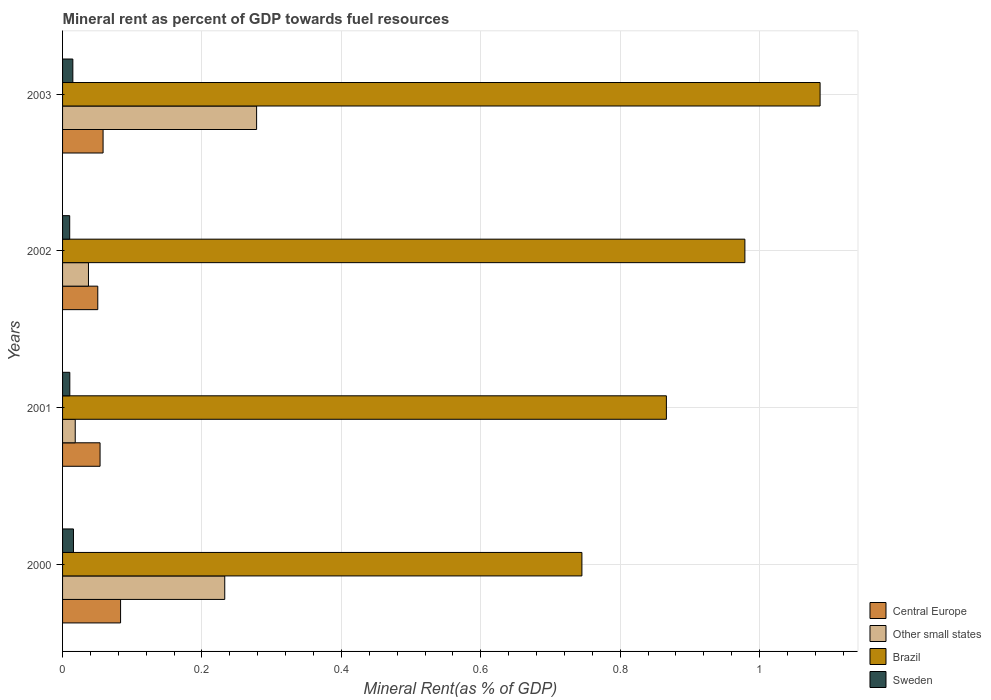How many different coloured bars are there?
Ensure brevity in your answer.  4. Are the number of bars on each tick of the Y-axis equal?
Ensure brevity in your answer.  Yes. How many bars are there on the 2nd tick from the top?
Offer a terse response. 4. What is the label of the 1st group of bars from the top?
Make the answer very short. 2003. In how many cases, is the number of bars for a given year not equal to the number of legend labels?
Make the answer very short. 0. What is the mineral rent in Central Europe in 2000?
Offer a very short reply. 0.08. Across all years, what is the maximum mineral rent in Sweden?
Make the answer very short. 0.02. Across all years, what is the minimum mineral rent in Sweden?
Your answer should be compact. 0.01. In which year was the mineral rent in Brazil maximum?
Your answer should be compact. 2003. What is the total mineral rent in Brazil in the graph?
Your answer should be very brief. 3.68. What is the difference between the mineral rent in Sweden in 2000 and that in 2003?
Make the answer very short. 0. What is the difference between the mineral rent in Sweden in 2001 and the mineral rent in Other small states in 2003?
Ensure brevity in your answer.  -0.27. What is the average mineral rent in Other small states per year?
Your answer should be compact. 0.14. In the year 2003, what is the difference between the mineral rent in Brazil and mineral rent in Sweden?
Offer a terse response. 1.07. What is the ratio of the mineral rent in Central Europe in 2000 to that in 2002?
Provide a short and direct response. 1.65. Is the mineral rent in Other small states in 2002 less than that in 2003?
Your answer should be compact. Yes. Is the difference between the mineral rent in Brazil in 2000 and 2001 greater than the difference between the mineral rent in Sweden in 2000 and 2001?
Make the answer very short. No. What is the difference between the highest and the second highest mineral rent in Sweden?
Make the answer very short. 0. What is the difference between the highest and the lowest mineral rent in Other small states?
Provide a succinct answer. 0.26. Is it the case that in every year, the sum of the mineral rent in Sweden and mineral rent in Central Europe is greater than the sum of mineral rent in Brazil and mineral rent in Other small states?
Offer a very short reply. Yes. What does the 4th bar from the top in 2000 represents?
Your answer should be very brief. Central Europe. What does the 1st bar from the bottom in 2000 represents?
Provide a short and direct response. Central Europe. Is it the case that in every year, the sum of the mineral rent in Brazil and mineral rent in Other small states is greater than the mineral rent in Sweden?
Keep it short and to the point. Yes. How many bars are there?
Keep it short and to the point. 16. Are the values on the major ticks of X-axis written in scientific E-notation?
Your response must be concise. No. Does the graph contain any zero values?
Provide a short and direct response. No. Where does the legend appear in the graph?
Offer a terse response. Bottom right. How many legend labels are there?
Make the answer very short. 4. What is the title of the graph?
Ensure brevity in your answer.  Mineral rent as percent of GDP towards fuel resources. Does "Dominican Republic" appear as one of the legend labels in the graph?
Your answer should be very brief. No. What is the label or title of the X-axis?
Provide a succinct answer. Mineral Rent(as % of GDP). What is the label or title of the Y-axis?
Provide a short and direct response. Years. What is the Mineral Rent(as % of GDP) in Central Europe in 2000?
Your answer should be compact. 0.08. What is the Mineral Rent(as % of GDP) in Other small states in 2000?
Offer a very short reply. 0.23. What is the Mineral Rent(as % of GDP) in Brazil in 2000?
Your answer should be very brief. 0.75. What is the Mineral Rent(as % of GDP) of Sweden in 2000?
Your answer should be very brief. 0.02. What is the Mineral Rent(as % of GDP) of Central Europe in 2001?
Your answer should be compact. 0.05. What is the Mineral Rent(as % of GDP) in Other small states in 2001?
Your answer should be very brief. 0.02. What is the Mineral Rent(as % of GDP) in Brazil in 2001?
Your answer should be very brief. 0.87. What is the Mineral Rent(as % of GDP) of Sweden in 2001?
Ensure brevity in your answer.  0.01. What is the Mineral Rent(as % of GDP) in Central Europe in 2002?
Offer a very short reply. 0.05. What is the Mineral Rent(as % of GDP) in Other small states in 2002?
Make the answer very short. 0.04. What is the Mineral Rent(as % of GDP) of Brazil in 2002?
Ensure brevity in your answer.  0.98. What is the Mineral Rent(as % of GDP) of Sweden in 2002?
Your answer should be very brief. 0.01. What is the Mineral Rent(as % of GDP) in Central Europe in 2003?
Keep it short and to the point. 0.06. What is the Mineral Rent(as % of GDP) of Other small states in 2003?
Provide a succinct answer. 0.28. What is the Mineral Rent(as % of GDP) of Brazil in 2003?
Your answer should be very brief. 1.09. What is the Mineral Rent(as % of GDP) of Sweden in 2003?
Ensure brevity in your answer.  0.01. Across all years, what is the maximum Mineral Rent(as % of GDP) in Central Europe?
Provide a succinct answer. 0.08. Across all years, what is the maximum Mineral Rent(as % of GDP) of Other small states?
Offer a very short reply. 0.28. Across all years, what is the maximum Mineral Rent(as % of GDP) of Brazil?
Your answer should be compact. 1.09. Across all years, what is the maximum Mineral Rent(as % of GDP) in Sweden?
Your answer should be very brief. 0.02. Across all years, what is the minimum Mineral Rent(as % of GDP) in Central Europe?
Offer a terse response. 0.05. Across all years, what is the minimum Mineral Rent(as % of GDP) in Other small states?
Provide a short and direct response. 0.02. Across all years, what is the minimum Mineral Rent(as % of GDP) of Brazil?
Ensure brevity in your answer.  0.75. Across all years, what is the minimum Mineral Rent(as % of GDP) in Sweden?
Your answer should be very brief. 0.01. What is the total Mineral Rent(as % of GDP) in Central Europe in the graph?
Offer a terse response. 0.25. What is the total Mineral Rent(as % of GDP) in Other small states in the graph?
Offer a very short reply. 0.57. What is the total Mineral Rent(as % of GDP) of Brazil in the graph?
Make the answer very short. 3.68. What is the total Mineral Rent(as % of GDP) in Sweden in the graph?
Your answer should be very brief. 0.05. What is the difference between the Mineral Rent(as % of GDP) in Central Europe in 2000 and that in 2001?
Your response must be concise. 0.03. What is the difference between the Mineral Rent(as % of GDP) of Other small states in 2000 and that in 2001?
Provide a short and direct response. 0.21. What is the difference between the Mineral Rent(as % of GDP) of Brazil in 2000 and that in 2001?
Keep it short and to the point. -0.12. What is the difference between the Mineral Rent(as % of GDP) in Sweden in 2000 and that in 2001?
Offer a terse response. 0.01. What is the difference between the Mineral Rent(as % of GDP) of Central Europe in 2000 and that in 2002?
Your answer should be very brief. 0.03. What is the difference between the Mineral Rent(as % of GDP) of Other small states in 2000 and that in 2002?
Offer a terse response. 0.2. What is the difference between the Mineral Rent(as % of GDP) of Brazil in 2000 and that in 2002?
Provide a succinct answer. -0.23. What is the difference between the Mineral Rent(as % of GDP) of Sweden in 2000 and that in 2002?
Give a very brief answer. 0.01. What is the difference between the Mineral Rent(as % of GDP) of Central Europe in 2000 and that in 2003?
Give a very brief answer. 0.03. What is the difference between the Mineral Rent(as % of GDP) in Other small states in 2000 and that in 2003?
Your response must be concise. -0.05. What is the difference between the Mineral Rent(as % of GDP) of Brazil in 2000 and that in 2003?
Provide a short and direct response. -0.34. What is the difference between the Mineral Rent(as % of GDP) in Sweden in 2000 and that in 2003?
Provide a short and direct response. 0. What is the difference between the Mineral Rent(as % of GDP) of Central Europe in 2001 and that in 2002?
Keep it short and to the point. 0. What is the difference between the Mineral Rent(as % of GDP) in Other small states in 2001 and that in 2002?
Give a very brief answer. -0.02. What is the difference between the Mineral Rent(as % of GDP) in Brazil in 2001 and that in 2002?
Give a very brief answer. -0.11. What is the difference between the Mineral Rent(as % of GDP) in Central Europe in 2001 and that in 2003?
Your answer should be compact. -0. What is the difference between the Mineral Rent(as % of GDP) in Other small states in 2001 and that in 2003?
Provide a short and direct response. -0.26. What is the difference between the Mineral Rent(as % of GDP) in Brazil in 2001 and that in 2003?
Provide a short and direct response. -0.22. What is the difference between the Mineral Rent(as % of GDP) in Sweden in 2001 and that in 2003?
Your response must be concise. -0. What is the difference between the Mineral Rent(as % of GDP) in Central Europe in 2002 and that in 2003?
Your answer should be compact. -0.01. What is the difference between the Mineral Rent(as % of GDP) in Other small states in 2002 and that in 2003?
Ensure brevity in your answer.  -0.24. What is the difference between the Mineral Rent(as % of GDP) of Brazil in 2002 and that in 2003?
Your answer should be compact. -0.11. What is the difference between the Mineral Rent(as % of GDP) of Sweden in 2002 and that in 2003?
Make the answer very short. -0. What is the difference between the Mineral Rent(as % of GDP) in Central Europe in 2000 and the Mineral Rent(as % of GDP) in Other small states in 2001?
Provide a succinct answer. 0.07. What is the difference between the Mineral Rent(as % of GDP) of Central Europe in 2000 and the Mineral Rent(as % of GDP) of Brazil in 2001?
Make the answer very short. -0.78. What is the difference between the Mineral Rent(as % of GDP) of Central Europe in 2000 and the Mineral Rent(as % of GDP) of Sweden in 2001?
Offer a terse response. 0.07. What is the difference between the Mineral Rent(as % of GDP) of Other small states in 2000 and the Mineral Rent(as % of GDP) of Brazil in 2001?
Ensure brevity in your answer.  -0.63. What is the difference between the Mineral Rent(as % of GDP) in Other small states in 2000 and the Mineral Rent(as % of GDP) in Sweden in 2001?
Your answer should be very brief. 0.22. What is the difference between the Mineral Rent(as % of GDP) of Brazil in 2000 and the Mineral Rent(as % of GDP) of Sweden in 2001?
Ensure brevity in your answer.  0.73. What is the difference between the Mineral Rent(as % of GDP) of Central Europe in 2000 and the Mineral Rent(as % of GDP) of Other small states in 2002?
Offer a terse response. 0.05. What is the difference between the Mineral Rent(as % of GDP) in Central Europe in 2000 and the Mineral Rent(as % of GDP) in Brazil in 2002?
Offer a terse response. -0.9. What is the difference between the Mineral Rent(as % of GDP) of Central Europe in 2000 and the Mineral Rent(as % of GDP) of Sweden in 2002?
Keep it short and to the point. 0.07. What is the difference between the Mineral Rent(as % of GDP) of Other small states in 2000 and the Mineral Rent(as % of GDP) of Brazil in 2002?
Your answer should be very brief. -0.75. What is the difference between the Mineral Rent(as % of GDP) in Other small states in 2000 and the Mineral Rent(as % of GDP) in Sweden in 2002?
Keep it short and to the point. 0.22. What is the difference between the Mineral Rent(as % of GDP) of Brazil in 2000 and the Mineral Rent(as % of GDP) of Sweden in 2002?
Provide a succinct answer. 0.73. What is the difference between the Mineral Rent(as % of GDP) in Central Europe in 2000 and the Mineral Rent(as % of GDP) in Other small states in 2003?
Ensure brevity in your answer.  -0.2. What is the difference between the Mineral Rent(as % of GDP) of Central Europe in 2000 and the Mineral Rent(as % of GDP) of Brazil in 2003?
Give a very brief answer. -1. What is the difference between the Mineral Rent(as % of GDP) in Central Europe in 2000 and the Mineral Rent(as % of GDP) in Sweden in 2003?
Give a very brief answer. 0.07. What is the difference between the Mineral Rent(as % of GDP) of Other small states in 2000 and the Mineral Rent(as % of GDP) of Brazil in 2003?
Make the answer very short. -0.85. What is the difference between the Mineral Rent(as % of GDP) in Other small states in 2000 and the Mineral Rent(as % of GDP) in Sweden in 2003?
Ensure brevity in your answer.  0.22. What is the difference between the Mineral Rent(as % of GDP) of Brazil in 2000 and the Mineral Rent(as % of GDP) of Sweden in 2003?
Ensure brevity in your answer.  0.73. What is the difference between the Mineral Rent(as % of GDP) of Central Europe in 2001 and the Mineral Rent(as % of GDP) of Other small states in 2002?
Your response must be concise. 0.02. What is the difference between the Mineral Rent(as % of GDP) of Central Europe in 2001 and the Mineral Rent(as % of GDP) of Brazil in 2002?
Your response must be concise. -0.93. What is the difference between the Mineral Rent(as % of GDP) in Central Europe in 2001 and the Mineral Rent(as % of GDP) in Sweden in 2002?
Your answer should be compact. 0.04. What is the difference between the Mineral Rent(as % of GDP) of Other small states in 2001 and the Mineral Rent(as % of GDP) of Brazil in 2002?
Provide a succinct answer. -0.96. What is the difference between the Mineral Rent(as % of GDP) in Other small states in 2001 and the Mineral Rent(as % of GDP) in Sweden in 2002?
Provide a succinct answer. 0.01. What is the difference between the Mineral Rent(as % of GDP) of Brazil in 2001 and the Mineral Rent(as % of GDP) of Sweden in 2002?
Make the answer very short. 0.86. What is the difference between the Mineral Rent(as % of GDP) of Central Europe in 2001 and the Mineral Rent(as % of GDP) of Other small states in 2003?
Offer a very short reply. -0.22. What is the difference between the Mineral Rent(as % of GDP) in Central Europe in 2001 and the Mineral Rent(as % of GDP) in Brazil in 2003?
Your answer should be compact. -1.03. What is the difference between the Mineral Rent(as % of GDP) of Central Europe in 2001 and the Mineral Rent(as % of GDP) of Sweden in 2003?
Give a very brief answer. 0.04. What is the difference between the Mineral Rent(as % of GDP) in Other small states in 2001 and the Mineral Rent(as % of GDP) in Brazil in 2003?
Provide a short and direct response. -1.07. What is the difference between the Mineral Rent(as % of GDP) of Other small states in 2001 and the Mineral Rent(as % of GDP) of Sweden in 2003?
Provide a succinct answer. 0. What is the difference between the Mineral Rent(as % of GDP) in Brazil in 2001 and the Mineral Rent(as % of GDP) in Sweden in 2003?
Give a very brief answer. 0.85. What is the difference between the Mineral Rent(as % of GDP) of Central Europe in 2002 and the Mineral Rent(as % of GDP) of Other small states in 2003?
Your answer should be compact. -0.23. What is the difference between the Mineral Rent(as % of GDP) in Central Europe in 2002 and the Mineral Rent(as % of GDP) in Brazil in 2003?
Make the answer very short. -1.04. What is the difference between the Mineral Rent(as % of GDP) in Central Europe in 2002 and the Mineral Rent(as % of GDP) in Sweden in 2003?
Provide a short and direct response. 0.04. What is the difference between the Mineral Rent(as % of GDP) in Other small states in 2002 and the Mineral Rent(as % of GDP) in Brazil in 2003?
Provide a succinct answer. -1.05. What is the difference between the Mineral Rent(as % of GDP) in Other small states in 2002 and the Mineral Rent(as % of GDP) in Sweden in 2003?
Ensure brevity in your answer.  0.02. What is the difference between the Mineral Rent(as % of GDP) in Brazil in 2002 and the Mineral Rent(as % of GDP) in Sweden in 2003?
Offer a very short reply. 0.96. What is the average Mineral Rent(as % of GDP) of Central Europe per year?
Your answer should be compact. 0.06. What is the average Mineral Rent(as % of GDP) in Other small states per year?
Provide a succinct answer. 0.14. What is the average Mineral Rent(as % of GDP) in Brazil per year?
Provide a succinct answer. 0.92. What is the average Mineral Rent(as % of GDP) in Sweden per year?
Your answer should be compact. 0.01. In the year 2000, what is the difference between the Mineral Rent(as % of GDP) of Central Europe and Mineral Rent(as % of GDP) of Other small states?
Provide a short and direct response. -0.15. In the year 2000, what is the difference between the Mineral Rent(as % of GDP) of Central Europe and Mineral Rent(as % of GDP) of Brazil?
Offer a terse response. -0.66. In the year 2000, what is the difference between the Mineral Rent(as % of GDP) in Central Europe and Mineral Rent(as % of GDP) in Sweden?
Offer a very short reply. 0.07. In the year 2000, what is the difference between the Mineral Rent(as % of GDP) of Other small states and Mineral Rent(as % of GDP) of Brazil?
Provide a short and direct response. -0.51. In the year 2000, what is the difference between the Mineral Rent(as % of GDP) in Other small states and Mineral Rent(as % of GDP) in Sweden?
Your answer should be compact. 0.22. In the year 2000, what is the difference between the Mineral Rent(as % of GDP) of Brazil and Mineral Rent(as % of GDP) of Sweden?
Offer a very short reply. 0.73. In the year 2001, what is the difference between the Mineral Rent(as % of GDP) of Central Europe and Mineral Rent(as % of GDP) of Other small states?
Provide a short and direct response. 0.04. In the year 2001, what is the difference between the Mineral Rent(as % of GDP) of Central Europe and Mineral Rent(as % of GDP) of Brazil?
Your answer should be compact. -0.81. In the year 2001, what is the difference between the Mineral Rent(as % of GDP) of Central Europe and Mineral Rent(as % of GDP) of Sweden?
Your response must be concise. 0.04. In the year 2001, what is the difference between the Mineral Rent(as % of GDP) of Other small states and Mineral Rent(as % of GDP) of Brazil?
Keep it short and to the point. -0.85. In the year 2001, what is the difference between the Mineral Rent(as % of GDP) in Other small states and Mineral Rent(as % of GDP) in Sweden?
Provide a succinct answer. 0.01. In the year 2001, what is the difference between the Mineral Rent(as % of GDP) in Brazil and Mineral Rent(as % of GDP) in Sweden?
Keep it short and to the point. 0.86. In the year 2002, what is the difference between the Mineral Rent(as % of GDP) in Central Europe and Mineral Rent(as % of GDP) in Other small states?
Offer a terse response. 0.01. In the year 2002, what is the difference between the Mineral Rent(as % of GDP) of Central Europe and Mineral Rent(as % of GDP) of Brazil?
Provide a short and direct response. -0.93. In the year 2002, what is the difference between the Mineral Rent(as % of GDP) of Central Europe and Mineral Rent(as % of GDP) of Sweden?
Provide a short and direct response. 0.04. In the year 2002, what is the difference between the Mineral Rent(as % of GDP) in Other small states and Mineral Rent(as % of GDP) in Brazil?
Your answer should be very brief. -0.94. In the year 2002, what is the difference between the Mineral Rent(as % of GDP) of Other small states and Mineral Rent(as % of GDP) of Sweden?
Offer a very short reply. 0.03. In the year 2002, what is the difference between the Mineral Rent(as % of GDP) in Brazil and Mineral Rent(as % of GDP) in Sweden?
Provide a short and direct response. 0.97. In the year 2003, what is the difference between the Mineral Rent(as % of GDP) of Central Europe and Mineral Rent(as % of GDP) of Other small states?
Provide a short and direct response. -0.22. In the year 2003, what is the difference between the Mineral Rent(as % of GDP) in Central Europe and Mineral Rent(as % of GDP) in Brazil?
Make the answer very short. -1.03. In the year 2003, what is the difference between the Mineral Rent(as % of GDP) of Central Europe and Mineral Rent(as % of GDP) of Sweden?
Offer a terse response. 0.04. In the year 2003, what is the difference between the Mineral Rent(as % of GDP) in Other small states and Mineral Rent(as % of GDP) in Brazil?
Your response must be concise. -0.81. In the year 2003, what is the difference between the Mineral Rent(as % of GDP) in Other small states and Mineral Rent(as % of GDP) in Sweden?
Your answer should be very brief. 0.26. In the year 2003, what is the difference between the Mineral Rent(as % of GDP) of Brazil and Mineral Rent(as % of GDP) of Sweden?
Offer a very short reply. 1.07. What is the ratio of the Mineral Rent(as % of GDP) of Central Europe in 2000 to that in 2001?
Make the answer very short. 1.55. What is the ratio of the Mineral Rent(as % of GDP) of Other small states in 2000 to that in 2001?
Your response must be concise. 12.81. What is the ratio of the Mineral Rent(as % of GDP) in Brazil in 2000 to that in 2001?
Provide a succinct answer. 0.86. What is the ratio of the Mineral Rent(as % of GDP) of Sweden in 2000 to that in 2001?
Offer a very short reply. 1.5. What is the ratio of the Mineral Rent(as % of GDP) of Central Europe in 2000 to that in 2002?
Offer a terse response. 1.65. What is the ratio of the Mineral Rent(as % of GDP) of Other small states in 2000 to that in 2002?
Provide a succinct answer. 6.26. What is the ratio of the Mineral Rent(as % of GDP) in Brazil in 2000 to that in 2002?
Offer a very short reply. 0.76. What is the ratio of the Mineral Rent(as % of GDP) in Sweden in 2000 to that in 2002?
Make the answer very short. 1.53. What is the ratio of the Mineral Rent(as % of GDP) of Central Europe in 2000 to that in 2003?
Offer a terse response. 1.43. What is the ratio of the Mineral Rent(as % of GDP) of Other small states in 2000 to that in 2003?
Your answer should be compact. 0.84. What is the ratio of the Mineral Rent(as % of GDP) in Brazil in 2000 to that in 2003?
Offer a very short reply. 0.69. What is the ratio of the Mineral Rent(as % of GDP) in Sweden in 2000 to that in 2003?
Give a very brief answer. 1.06. What is the ratio of the Mineral Rent(as % of GDP) in Central Europe in 2001 to that in 2002?
Your answer should be compact. 1.06. What is the ratio of the Mineral Rent(as % of GDP) in Other small states in 2001 to that in 2002?
Make the answer very short. 0.49. What is the ratio of the Mineral Rent(as % of GDP) in Brazil in 2001 to that in 2002?
Your answer should be compact. 0.88. What is the ratio of the Mineral Rent(as % of GDP) of Sweden in 2001 to that in 2002?
Provide a short and direct response. 1.01. What is the ratio of the Mineral Rent(as % of GDP) in Central Europe in 2001 to that in 2003?
Your response must be concise. 0.93. What is the ratio of the Mineral Rent(as % of GDP) in Other small states in 2001 to that in 2003?
Keep it short and to the point. 0.07. What is the ratio of the Mineral Rent(as % of GDP) of Brazil in 2001 to that in 2003?
Offer a very short reply. 0.8. What is the ratio of the Mineral Rent(as % of GDP) in Sweden in 2001 to that in 2003?
Provide a short and direct response. 0.71. What is the ratio of the Mineral Rent(as % of GDP) of Central Europe in 2002 to that in 2003?
Ensure brevity in your answer.  0.87. What is the ratio of the Mineral Rent(as % of GDP) of Other small states in 2002 to that in 2003?
Provide a short and direct response. 0.13. What is the ratio of the Mineral Rent(as % of GDP) in Brazil in 2002 to that in 2003?
Provide a succinct answer. 0.9. What is the ratio of the Mineral Rent(as % of GDP) of Sweden in 2002 to that in 2003?
Ensure brevity in your answer.  0.7. What is the difference between the highest and the second highest Mineral Rent(as % of GDP) of Central Europe?
Make the answer very short. 0.03. What is the difference between the highest and the second highest Mineral Rent(as % of GDP) in Other small states?
Keep it short and to the point. 0.05. What is the difference between the highest and the second highest Mineral Rent(as % of GDP) of Brazil?
Your answer should be very brief. 0.11. What is the difference between the highest and the second highest Mineral Rent(as % of GDP) in Sweden?
Keep it short and to the point. 0. What is the difference between the highest and the lowest Mineral Rent(as % of GDP) of Central Europe?
Make the answer very short. 0.03. What is the difference between the highest and the lowest Mineral Rent(as % of GDP) in Other small states?
Your response must be concise. 0.26. What is the difference between the highest and the lowest Mineral Rent(as % of GDP) of Brazil?
Give a very brief answer. 0.34. What is the difference between the highest and the lowest Mineral Rent(as % of GDP) in Sweden?
Provide a short and direct response. 0.01. 